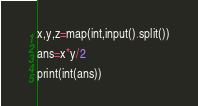Convert code to text. <code><loc_0><loc_0><loc_500><loc_500><_Python_>x,y,z=map(int,input().split())

ans=x*y/2

print(int(ans))</code> 